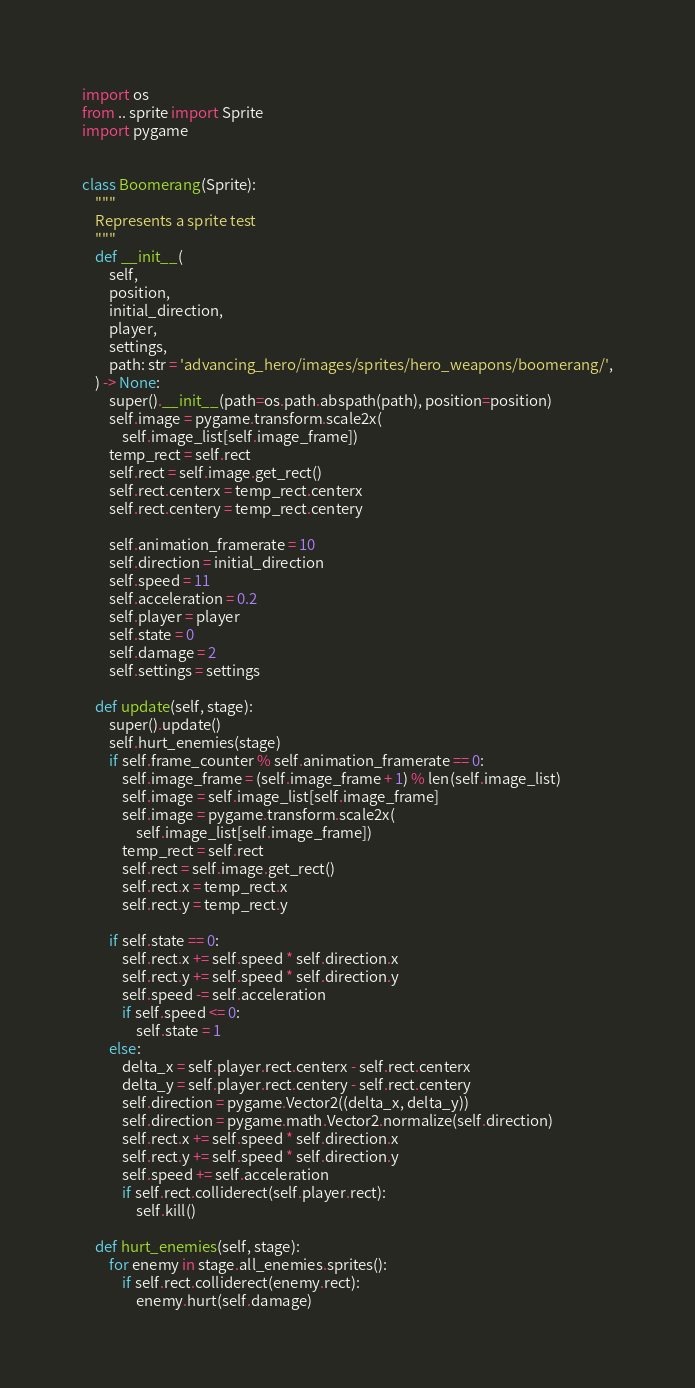Convert code to text. <code><loc_0><loc_0><loc_500><loc_500><_Python_>import os
from .. sprite import Sprite
import pygame


class Boomerang(Sprite):
    """
    Represents a sprite test
    """
    def __init__(
        self,
        position,
        initial_direction,
        player,
        settings,
        path: str = 'advancing_hero/images/sprites/hero_weapons/boomerang/',
    ) -> None:
        super().__init__(path=os.path.abspath(path), position=position)
        self.image = pygame.transform.scale2x(
            self.image_list[self.image_frame])
        temp_rect = self.rect
        self.rect = self.image.get_rect()
        self.rect.centerx = temp_rect.centerx
        self.rect.centery = temp_rect.centery

        self.animation_framerate = 10
        self.direction = initial_direction
        self.speed = 11
        self.acceleration = 0.2
        self.player = player
        self.state = 0
        self.damage = 2
        self.settings = settings

    def update(self, stage):
        super().update()
        self.hurt_enemies(stage)
        if self.frame_counter % self.animation_framerate == 0:
            self.image_frame = (self.image_frame + 1) % len(self.image_list)
            self.image = self.image_list[self.image_frame]
            self.image = pygame.transform.scale2x(
                self.image_list[self.image_frame])
            temp_rect = self.rect
            self.rect = self.image.get_rect()
            self.rect.x = temp_rect.x
            self.rect.y = temp_rect.y

        if self.state == 0:
            self.rect.x += self.speed * self.direction.x
            self.rect.y += self.speed * self.direction.y
            self.speed -= self.acceleration
            if self.speed <= 0:
                self.state = 1
        else:
            delta_x = self.player.rect.centerx - self.rect.centerx
            delta_y = self.player.rect.centery - self.rect.centery
            self.direction = pygame.Vector2((delta_x, delta_y))
            self.direction = pygame.math.Vector2.normalize(self.direction)
            self.rect.x += self.speed * self.direction.x
            self.rect.y += self.speed * self.direction.y
            self.speed += self.acceleration
            if self.rect.colliderect(self.player.rect):
                self.kill()

    def hurt_enemies(self, stage):
        for enemy in stage.all_enemies.sprites():
            if self.rect.colliderect(enemy.rect):
                enemy.hurt(self.damage)</code> 